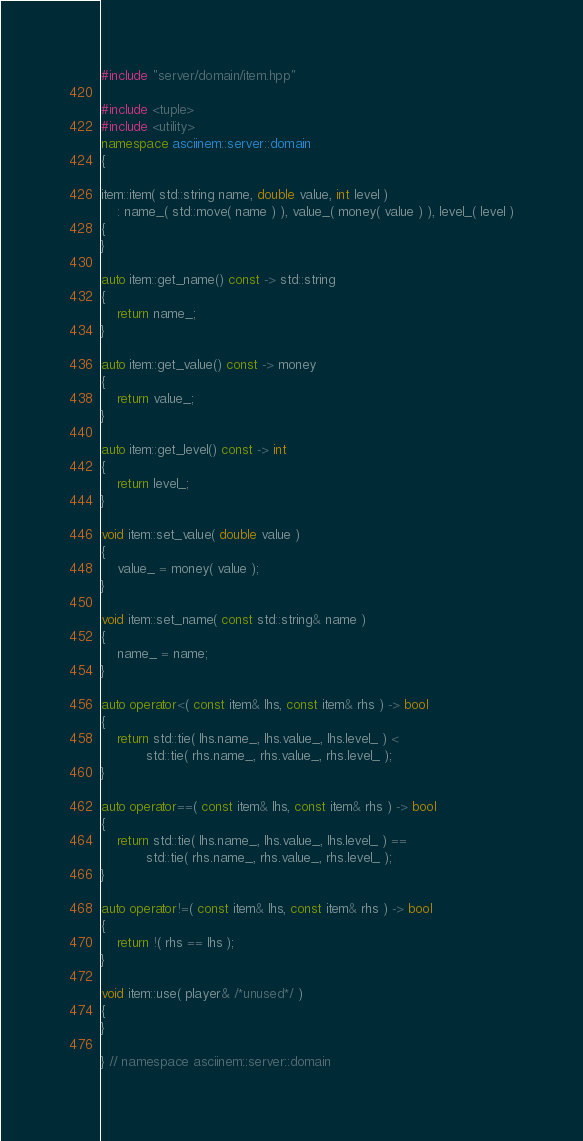Convert code to text. <code><loc_0><loc_0><loc_500><loc_500><_C++_>#include "server/domain/item.hpp"

#include <tuple>
#include <utility>
namespace asciinem::server::domain
{

item::item( std::string name, double value, int level )
    : name_( std::move( name ) ), value_( money( value ) ), level_( level )
{
}

auto item::get_name() const -> std::string
{
    return name_;
}

auto item::get_value() const -> money
{
    return value_;
}

auto item::get_level() const -> int
{
    return level_;
}

void item::set_value( double value )
{
    value_ = money( value );
}

void item::set_name( const std::string& name )
{
    name_ = name;
}

auto operator<( const item& lhs, const item& rhs ) -> bool
{
    return std::tie( lhs.name_, lhs.value_, lhs.level_ ) <
           std::tie( rhs.name_, rhs.value_, rhs.level_ );
}

auto operator==( const item& lhs, const item& rhs ) -> bool
{
    return std::tie( lhs.name_, lhs.value_, lhs.level_ ) ==
           std::tie( rhs.name_, rhs.value_, rhs.level_ );
}

auto operator!=( const item& lhs, const item& rhs ) -> bool
{
    return !( rhs == lhs );
}

void item::use( player& /*unused*/ )
{
}

} // namespace asciinem::server::domain
</code> 